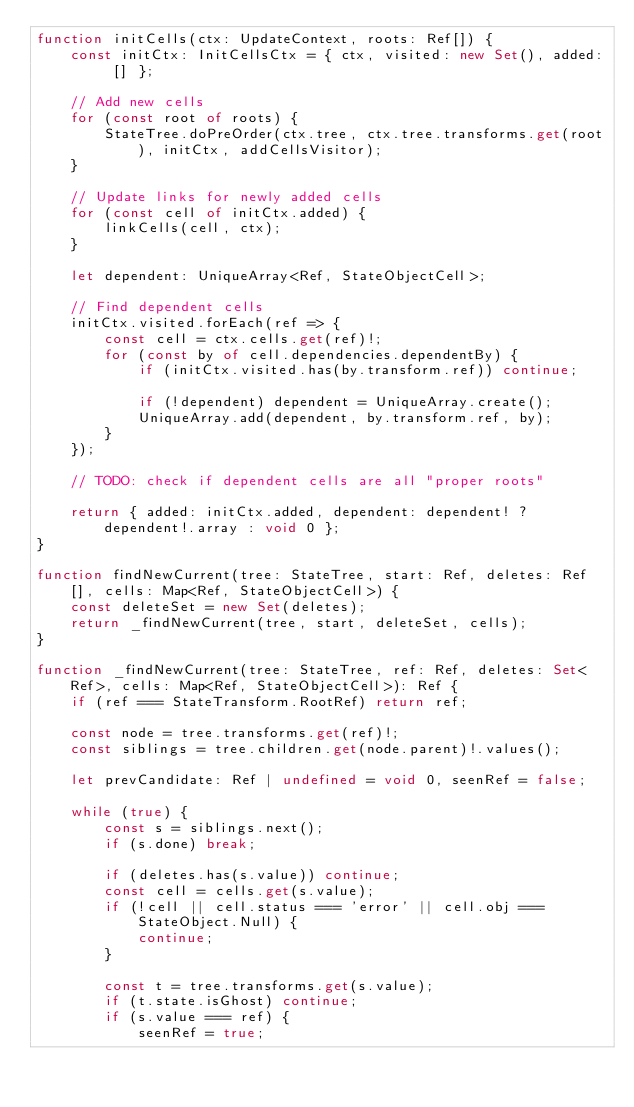<code> <loc_0><loc_0><loc_500><loc_500><_TypeScript_>function initCells(ctx: UpdateContext, roots: Ref[]) {
    const initCtx: InitCellsCtx = { ctx, visited: new Set(), added: [] };

    // Add new cells
    for (const root of roots) {
        StateTree.doPreOrder(ctx.tree, ctx.tree.transforms.get(root), initCtx, addCellsVisitor);
    }

    // Update links for newly added cells
    for (const cell of initCtx.added) {
        linkCells(cell, ctx);
    }

    let dependent: UniqueArray<Ref, StateObjectCell>;

    // Find dependent cells
    initCtx.visited.forEach(ref => {
        const cell = ctx.cells.get(ref)!;
        for (const by of cell.dependencies.dependentBy) {
            if (initCtx.visited.has(by.transform.ref)) continue;

            if (!dependent) dependent = UniqueArray.create();
            UniqueArray.add(dependent, by.transform.ref, by);
        }
    });

    // TODO: check if dependent cells are all "proper roots"

    return { added: initCtx.added, dependent: dependent! ? dependent!.array : void 0 };
}

function findNewCurrent(tree: StateTree, start: Ref, deletes: Ref[], cells: Map<Ref, StateObjectCell>) {
    const deleteSet = new Set(deletes);
    return _findNewCurrent(tree, start, deleteSet, cells);
}

function _findNewCurrent(tree: StateTree, ref: Ref, deletes: Set<Ref>, cells: Map<Ref, StateObjectCell>): Ref {
    if (ref === StateTransform.RootRef) return ref;

    const node = tree.transforms.get(ref)!;
    const siblings = tree.children.get(node.parent)!.values();

    let prevCandidate: Ref | undefined = void 0, seenRef = false;

    while (true) {
        const s = siblings.next();
        if (s.done) break;

        if (deletes.has(s.value)) continue;
        const cell = cells.get(s.value);
        if (!cell || cell.status === 'error' || cell.obj === StateObject.Null) {
            continue;
        }

        const t = tree.transforms.get(s.value);
        if (t.state.isGhost) continue;
        if (s.value === ref) {
            seenRef = true;</code> 